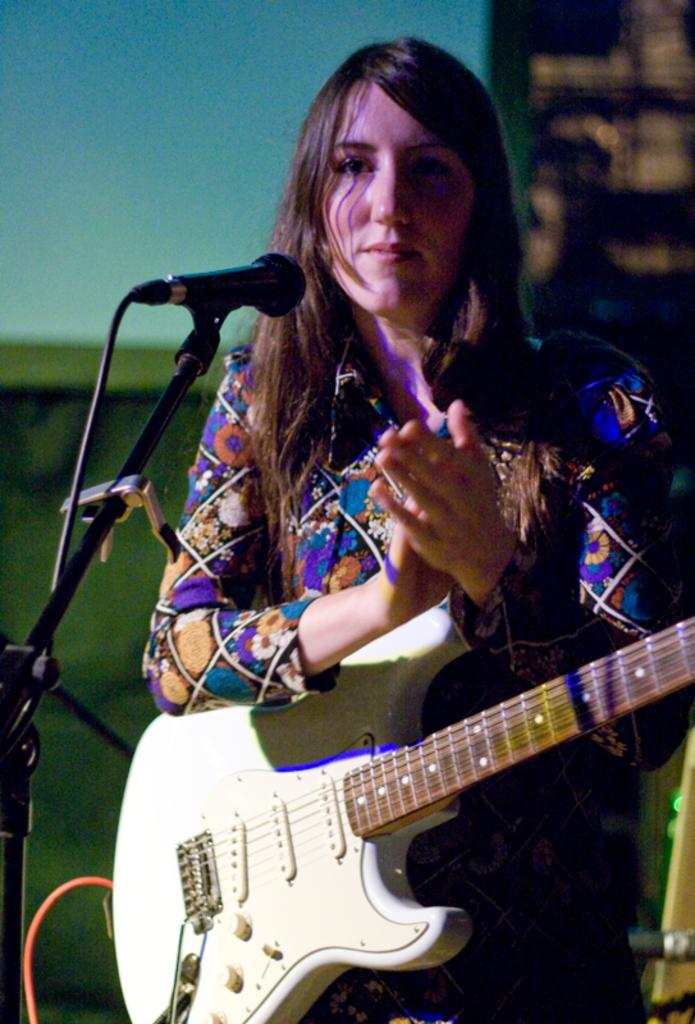What is the main subject of the image? The main subject of the image is a woman. What is the woman doing in the image? The woman is standing and holding a guitar. What object is present in the image that is typically used for amplifying sound? There is a microphone in the image, and it is on a stand. What color is the dress the woman is wearing? The woman is wearing a blue dress. Can you tell me where the woman's nest is located in the image? There is no nest present in the image; it features a woman holding a guitar and standing near a microphone. What hobbies does the woman have, based on the objects in the image? The image does not provide information about the woman's hobbies, only that she is holding a guitar and standing near a microphone. 